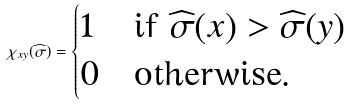Convert formula to latex. <formula><loc_0><loc_0><loc_500><loc_500>\chi _ { x y } ( \widehat { \sigma } ) = \begin{cases} 1 & \text {if $\widehat{\sigma }(x)>\widehat{\sigma }(y)$} \\ 0 & \text {otherwise} . \end{cases}</formula> 